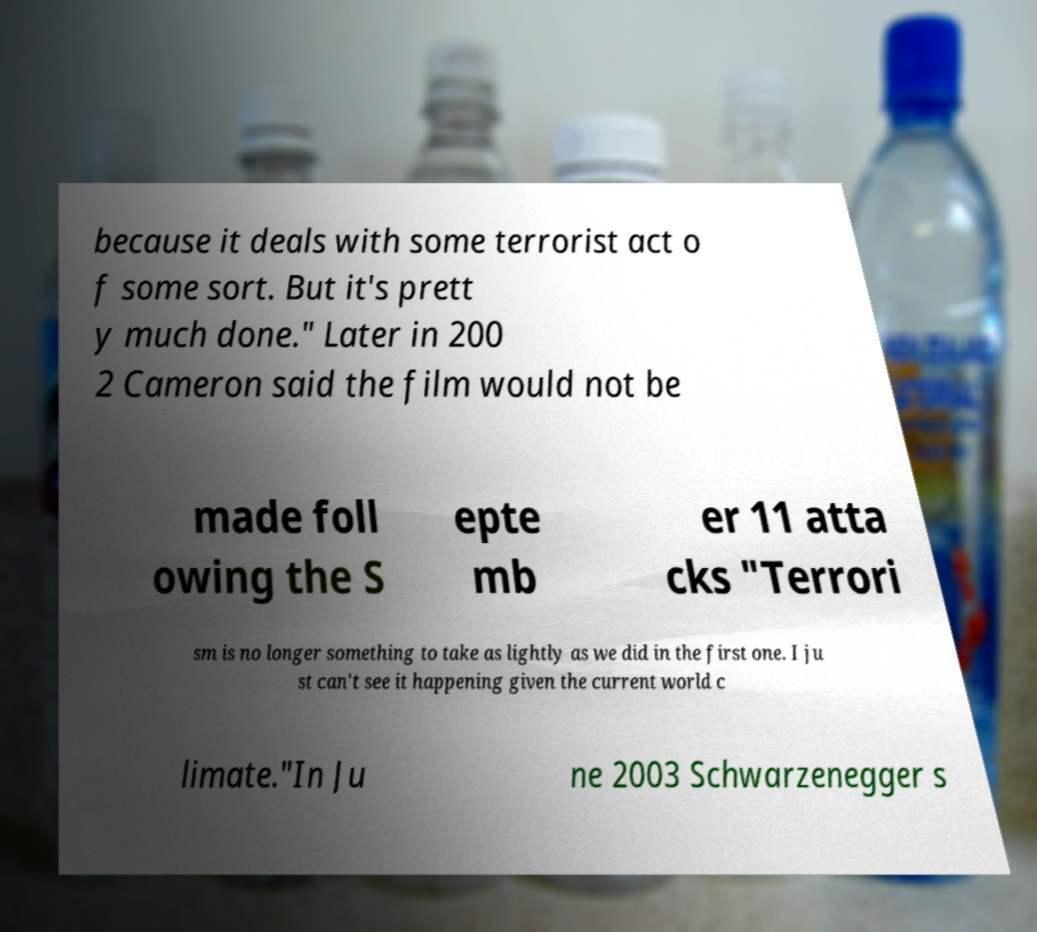Can you read and provide the text displayed in the image?This photo seems to have some interesting text. Can you extract and type it out for me? because it deals with some terrorist act o f some sort. But it's prett y much done." Later in 200 2 Cameron said the film would not be made foll owing the S epte mb er 11 atta cks "Terrori sm is no longer something to take as lightly as we did in the first one. I ju st can't see it happening given the current world c limate."In Ju ne 2003 Schwarzenegger s 